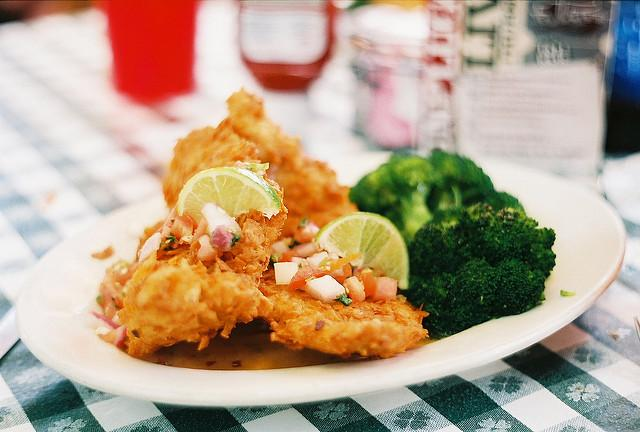What citrus fruit is atop the fried food? Please explain your reasoning. lime. The fruit looks similar to a lemon, but is green. 